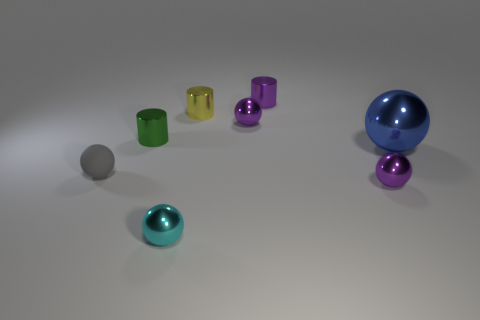Subtract all cyan balls. How many balls are left? 4 Subtract all blue spheres. How many spheres are left? 4 Subtract all red balls. Subtract all blue cylinders. How many balls are left? 5 Add 2 tiny brown rubber blocks. How many objects exist? 10 Subtract all balls. How many objects are left? 3 Subtract 1 purple cylinders. How many objects are left? 7 Subtract all blue spheres. Subtract all big spheres. How many objects are left? 6 Add 1 cyan balls. How many cyan balls are left? 2 Add 4 spheres. How many spheres exist? 9 